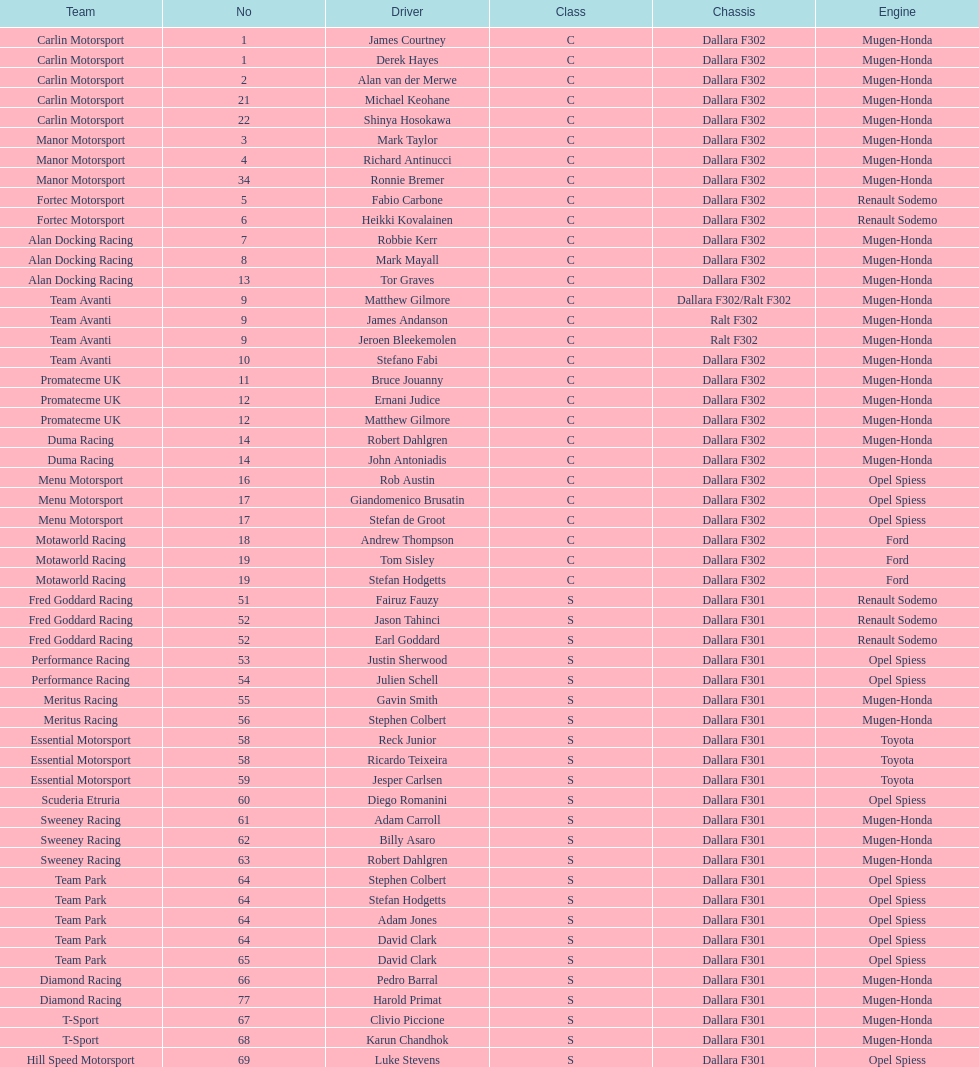Who possessed more drivers, team avanti or motaworld racing? Team Avanti. 